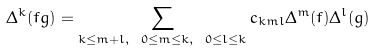Convert formula to latex. <formula><loc_0><loc_0><loc_500><loc_500>\Delta ^ { k } ( f g ) = \sum _ { k \leq m + l , \ 0 \leq m \leq k , \ 0 \leq l \leq k } c _ { k m l } \Delta ^ { m } ( f ) \Delta ^ { l } ( g )</formula> 